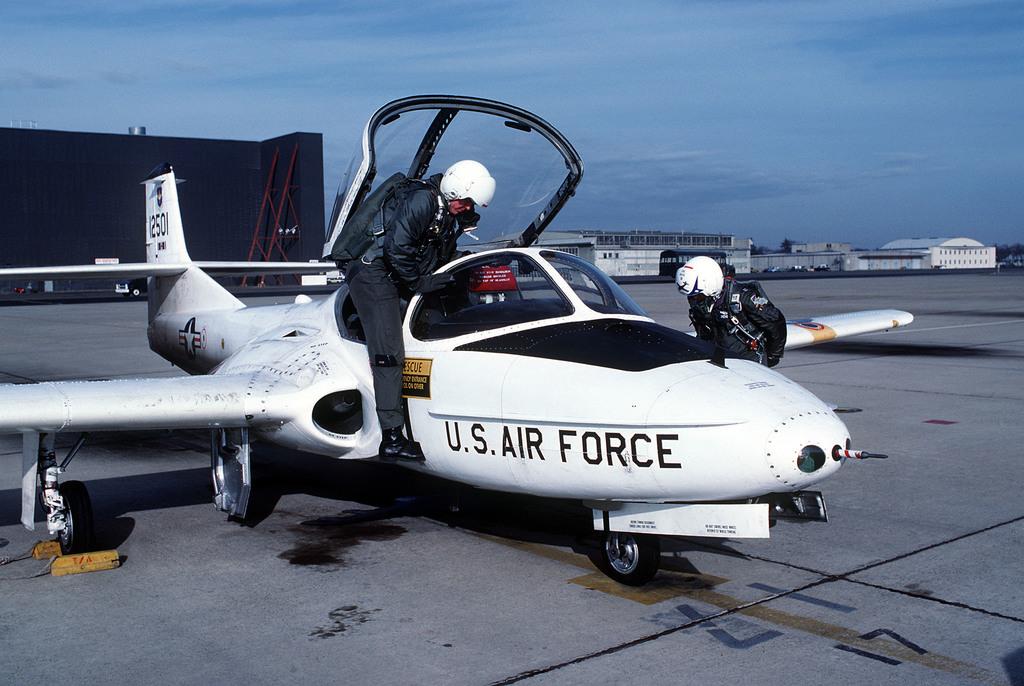Which branch is the plane from?
Your response must be concise. U.s. air force. What branch of the military owns this plane?
Your response must be concise. Air force. 